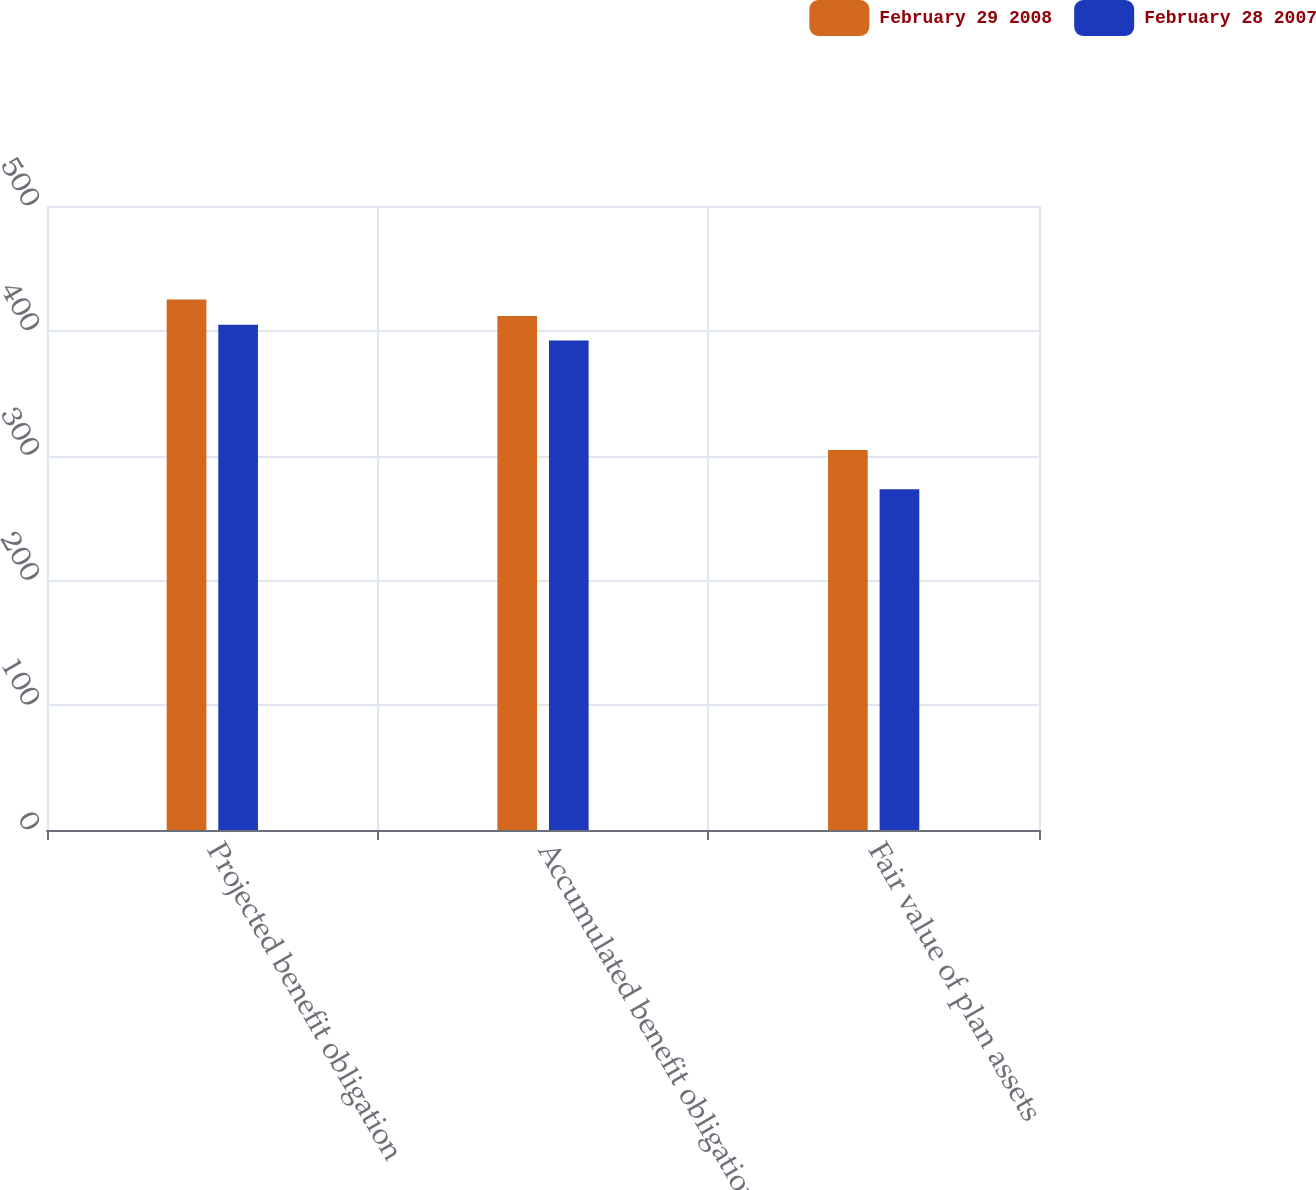<chart> <loc_0><loc_0><loc_500><loc_500><stacked_bar_chart><ecel><fcel>Projected benefit obligation<fcel>Accumulated benefit obligation<fcel>Fair value of plan assets<nl><fcel>February 29 2008<fcel>425.1<fcel>411.9<fcel>304.4<nl><fcel>February 28 2007<fcel>404.9<fcel>392.2<fcel>273.1<nl></chart> 